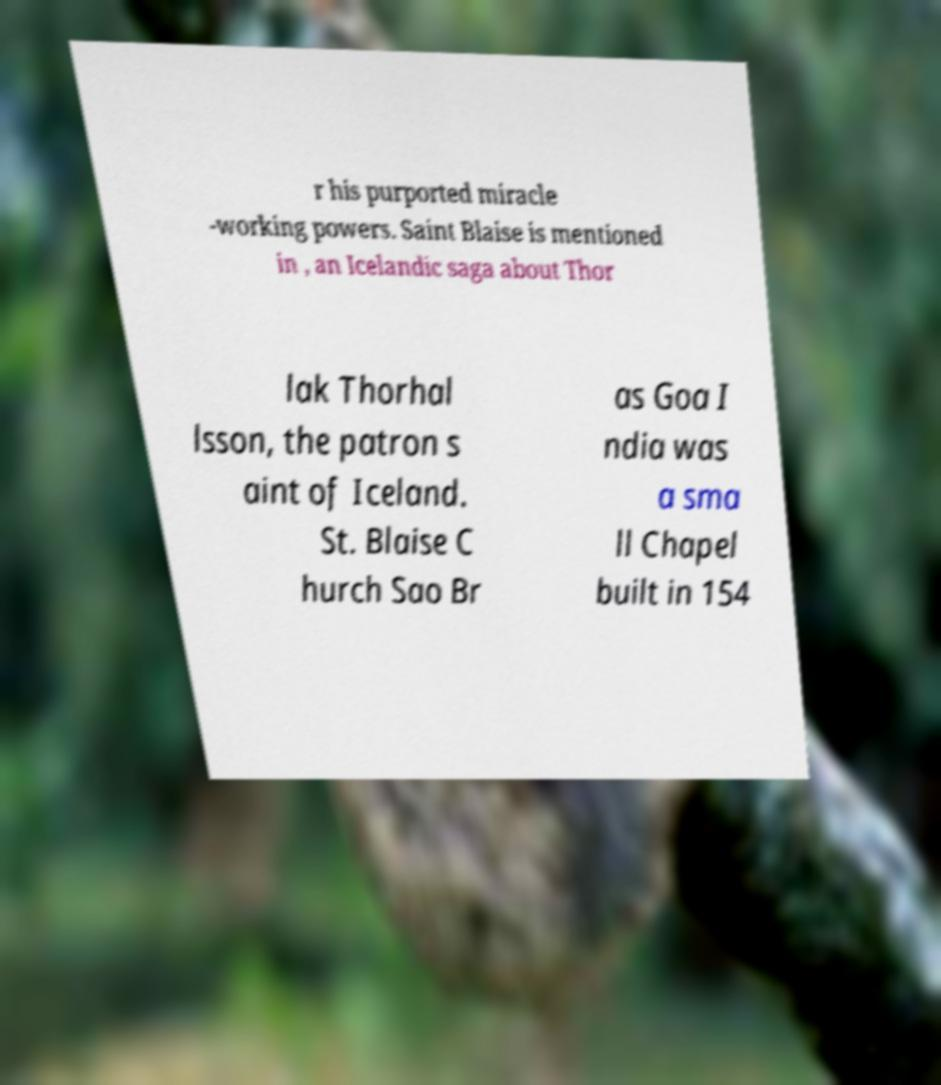Could you assist in decoding the text presented in this image and type it out clearly? r his purported miracle -working powers. Saint Blaise is mentioned in , an Icelandic saga about Thor lak Thorhal lsson, the patron s aint of Iceland. St. Blaise C hurch Sao Br as Goa I ndia was a sma ll Chapel built in 154 